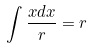<formula> <loc_0><loc_0><loc_500><loc_500>\int \frac { x d x } { r } = r</formula> 